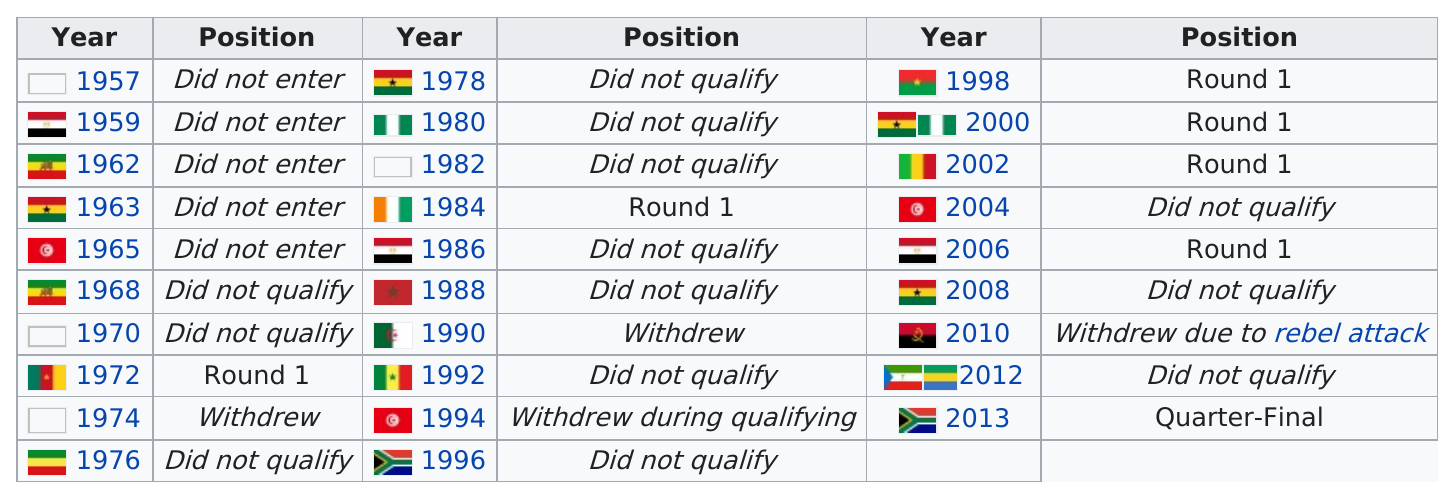Point out several critical features in this image. In 2013, Togo advanced beyond the first round of a tournament. The total number of nations that advanced to round 1 but did not progress past that round from 1957 to 2013 is 6. During the period of 1990 to 2012, a total of three nations withdrew from the United Nations. The team's performance the year after they withdrew due to rebel attacks did not qualify. It took approximately 12 years for the person to reach the same round again after finishing the first round. 